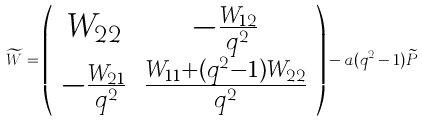Convert formula to latex. <formula><loc_0><loc_0><loc_500><loc_500>\widetilde { W } = \left ( \begin{array} { c c } W _ { 2 2 } & - \frac { W _ { 1 2 } } { q ^ { 2 } } \\ - \frac { W _ { 2 1 } } { q ^ { 2 } } & \frac { W _ { 1 1 } + ( q ^ { 2 } - 1 ) W _ { 2 2 } } { q ^ { 2 } } \end{array} \right ) - a ( q ^ { 2 } - 1 ) \widetilde { P }</formula> 